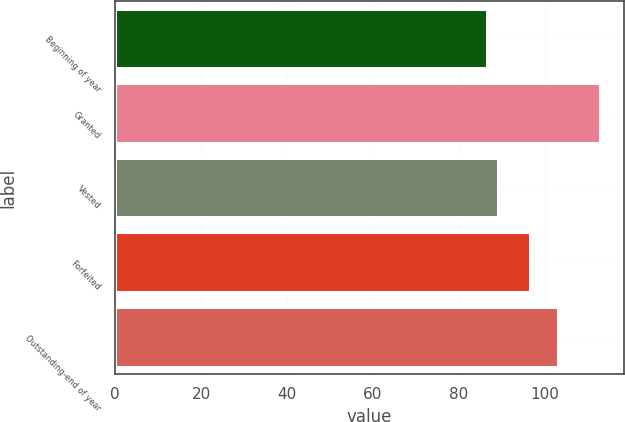Convert chart. <chart><loc_0><loc_0><loc_500><loc_500><bar_chart><fcel>Beginning of year<fcel>Granted<fcel>Vested<fcel>Forfeited<fcel>Outstanding-end of year<nl><fcel>86.47<fcel>112.72<fcel>89.09<fcel>96.53<fcel>103.05<nl></chart> 